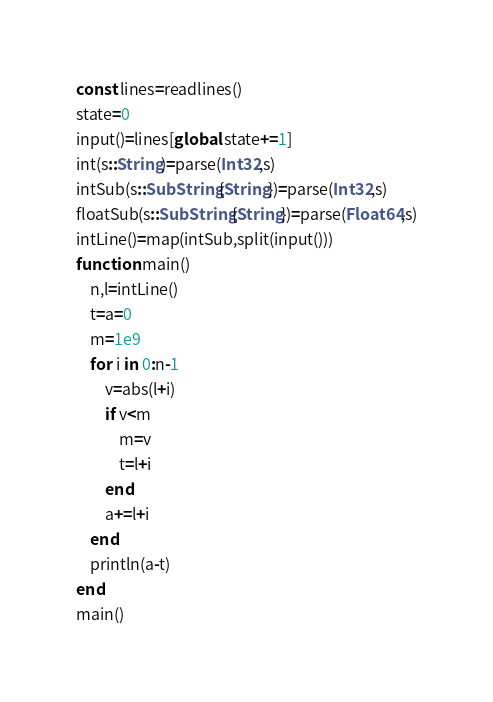Convert code to text. <code><loc_0><loc_0><loc_500><loc_500><_Julia_>const lines=readlines()
state=0
input()=lines[global state+=1]
int(s::String)=parse(Int32,s)
intSub(s::SubString{String})=parse(Int32,s)
floatSub(s::SubString{String})=parse(Float64,s)
intLine()=map(intSub,split(input()))
function main()
    n,l=intLine()
    t=a=0
    m=1e9
    for i in 0:n-1
        v=abs(l+i)
        if v<m
            m=v
            t=l+i
        end
        a+=l+i
    end
    println(a-t)
end
main()</code> 